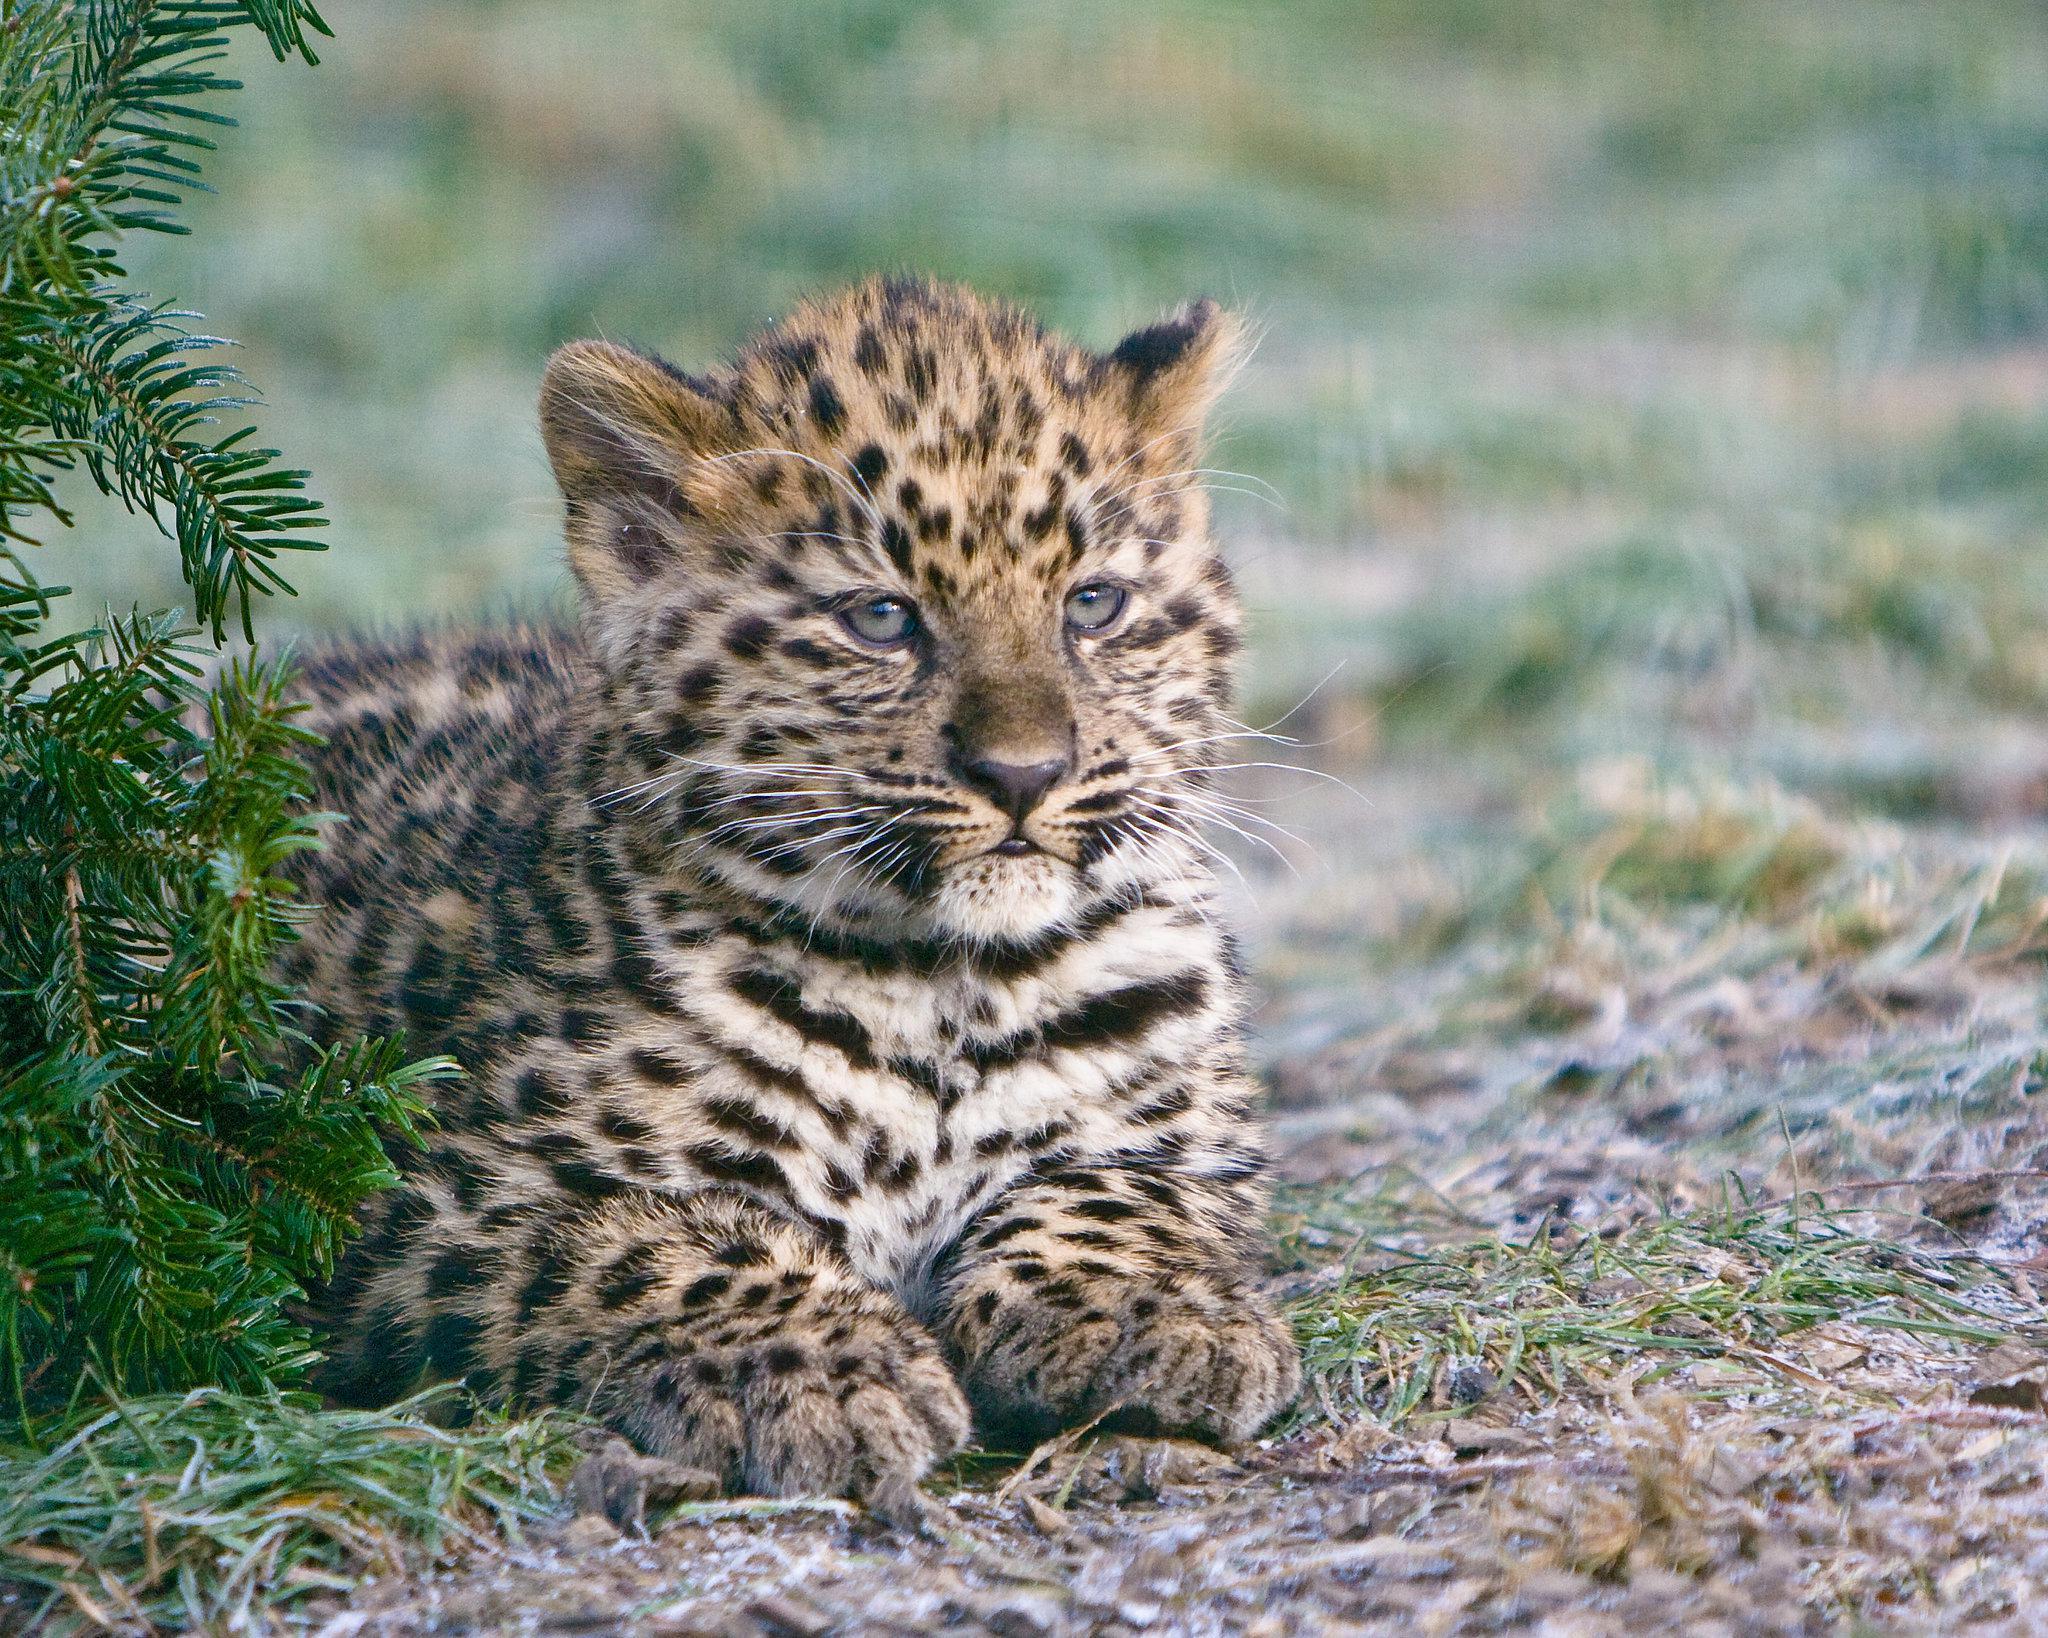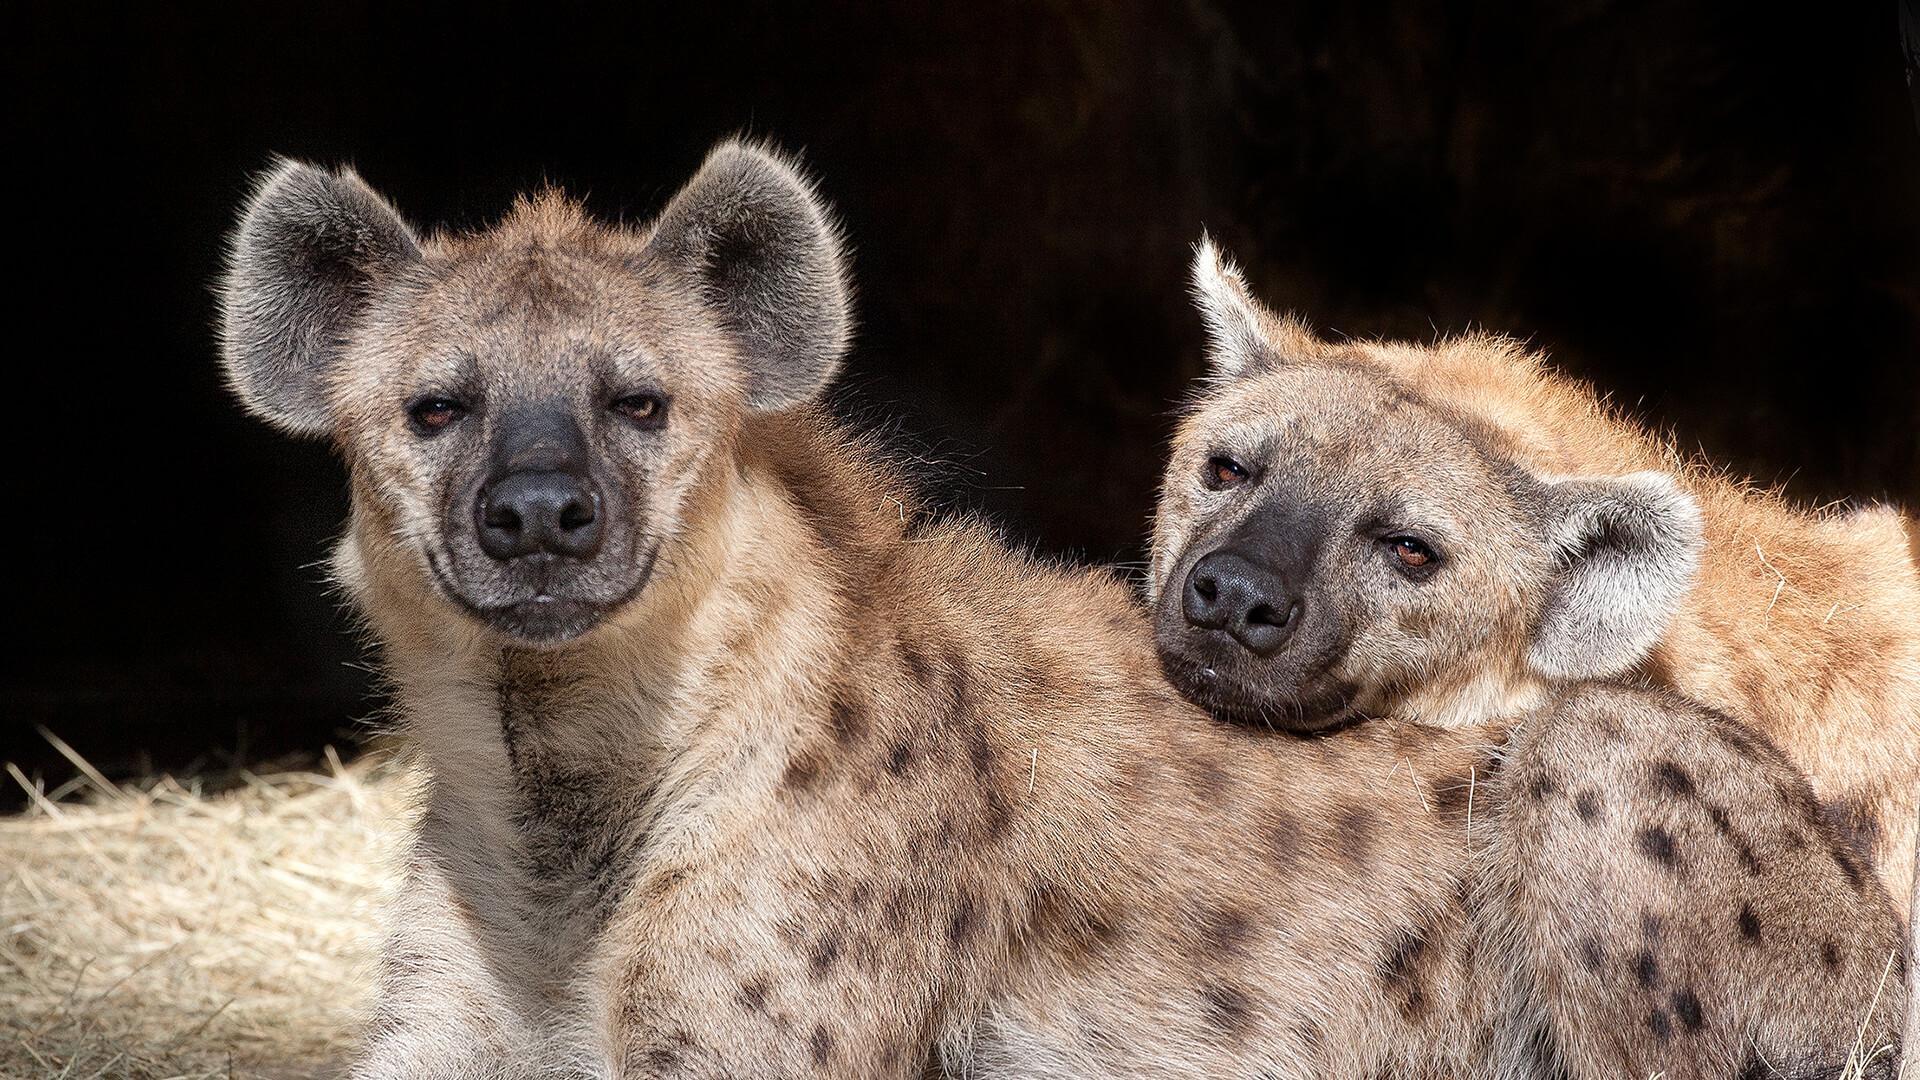The first image is the image on the left, the second image is the image on the right. For the images displayed, is the sentence "The animal in the image on the left is lying on the ground." factually correct? Answer yes or no. Yes. The first image is the image on the left, the second image is the image on the right. Analyze the images presented: Is the assertion "There are four hyenas in the image pair." valid? Answer yes or no. No. 